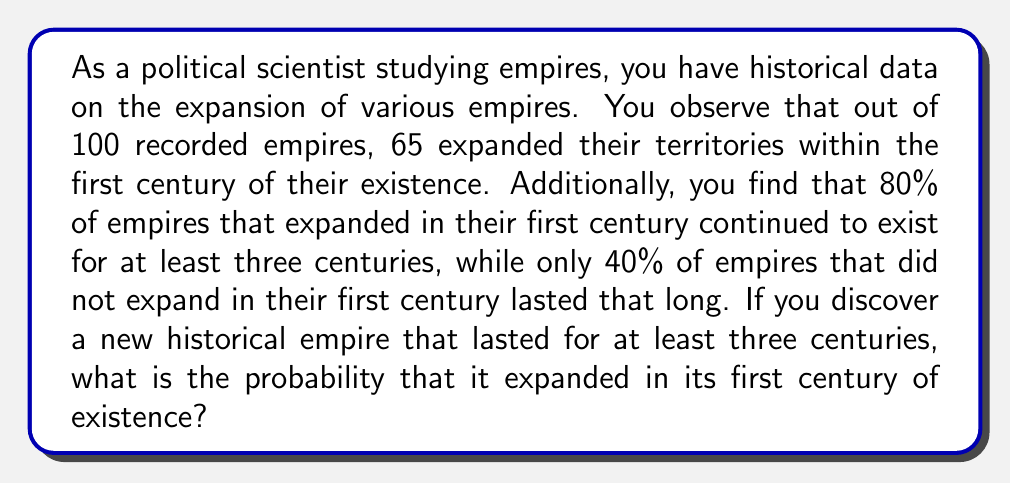Could you help me with this problem? To solve this problem, we'll use Bayes' theorem. Let's define our events:

$A$: The empire expanded in its first century
$B$: The empire lasted for at least three centuries

We need to find $P(A|B)$, the probability that the empire expanded in its first century given that it lasted for at least three centuries.

Bayes' theorem states:

$$P(A|B) = \frac{P(B|A) \cdot P(A)}{P(B)}$$

From the given information:
$P(A) = 65/100 = 0.65$ (probability of expansion in the first century)
$P(B|A) = 0.80$ (probability of lasting three centuries given expansion)
$P(B|\text{not }A) = 0.40$ (probability of lasting three centuries given no expansion)

We need to calculate $P(B)$ using the law of total probability:

$$P(B) = P(B|A) \cdot P(A) + P(B|\text{not }A) \cdot P(\text{not }A)$$

$P(\text{not }A) = 1 - P(A) = 1 - 0.65 = 0.35$

$$P(B) = 0.80 \cdot 0.65 + 0.40 \cdot 0.35 = 0.52 + 0.14 = 0.66$$

Now we can apply Bayes' theorem:

$$P(A|B) = \frac{0.80 \cdot 0.65}{0.66} \approx 0.7879$$
Answer: The probability that the empire expanded in its first century, given that it lasted for at least three centuries, is approximately 0.7879 or 78.79%. 